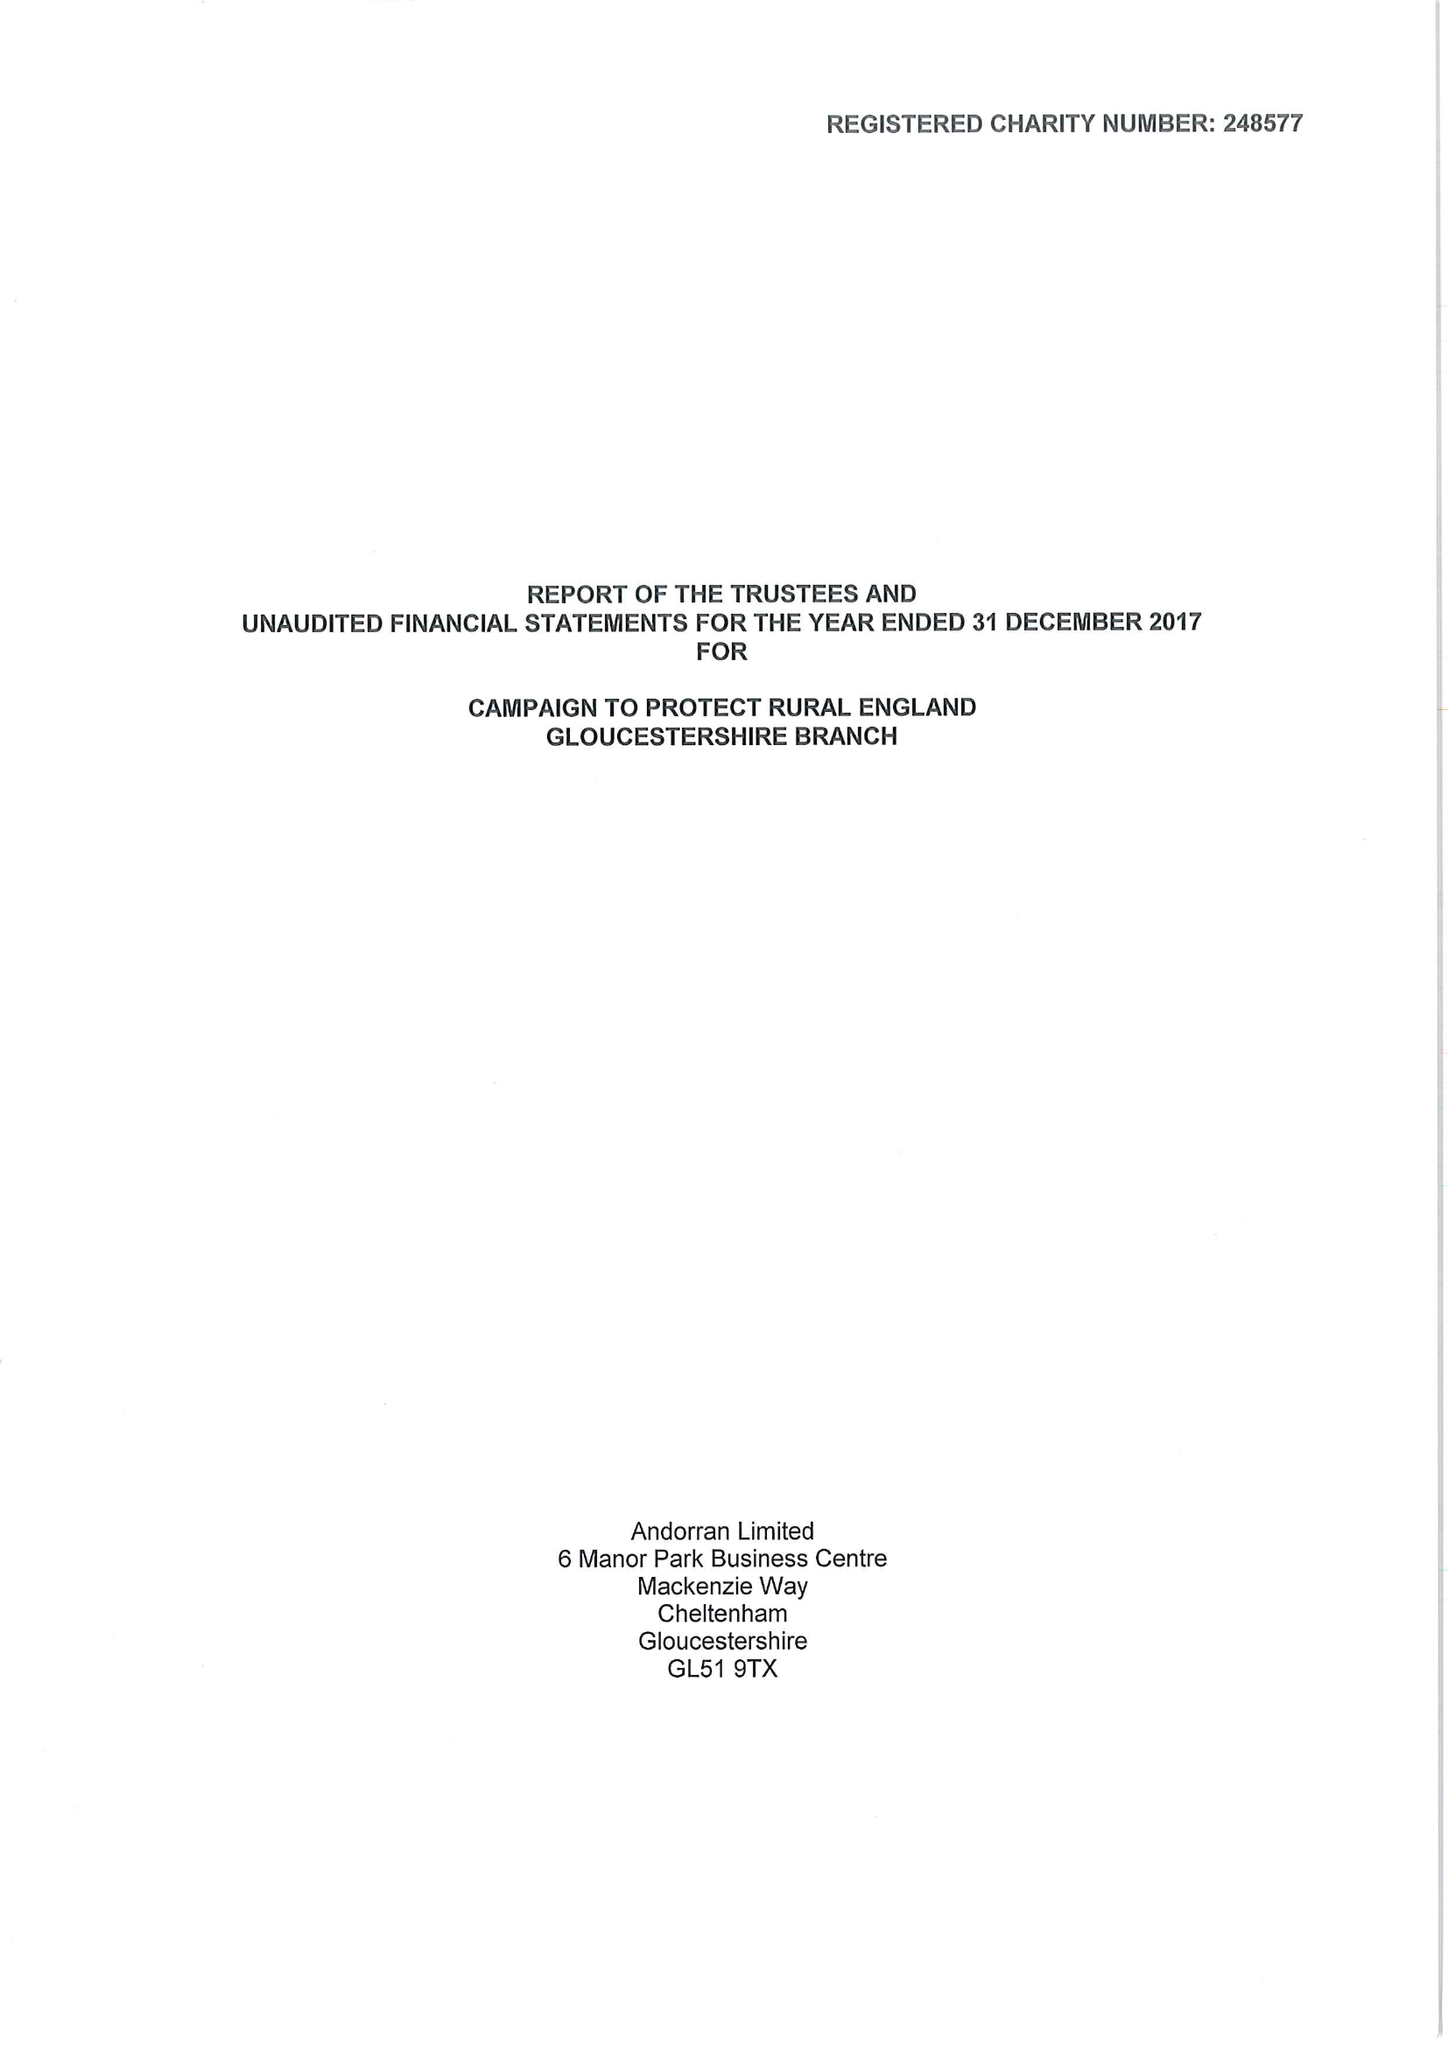What is the value for the income_annually_in_british_pounds?
Answer the question using a single word or phrase. 28320.00 